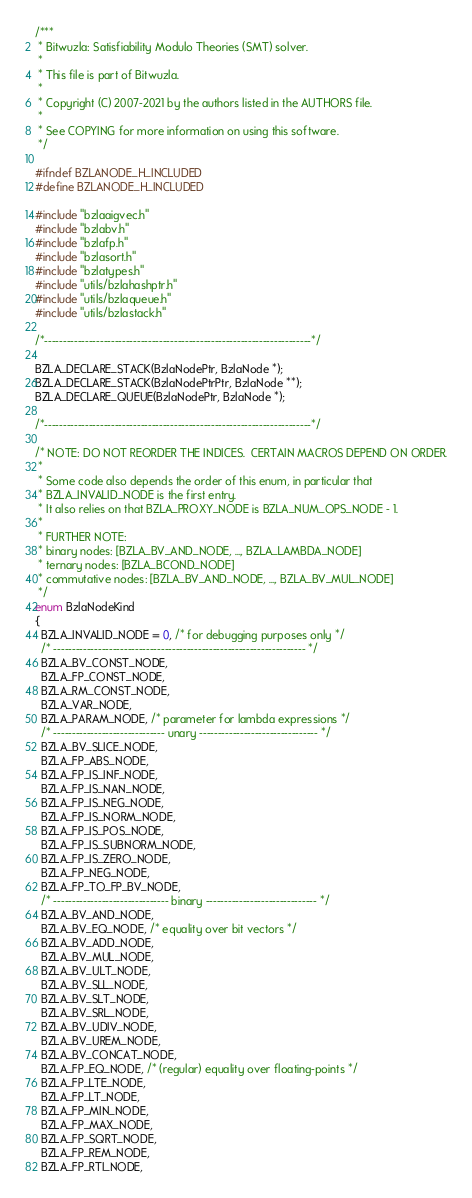Convert code to text. <code><loc_0><loc_0><loc_500><loc_500><_C_>/***
 * Bitwuzla: Satisfiability Modulo Theories (SMT) solver.
 *
 * This file is part of Bitwuzla.
 *
 * Copyright (C) 2007-2021 by the authors listed in the AUTHORS file.
 *
 * See COPYING for more information on using this software.
 */

#ifndef BZLANODE_H_INCLUDED
#define BZLANODE_H_INCLUDED

#include "bzlaaigvec.h"
#include "bzlabv.h"
#include "bzlafp.h"
#include "bzlasort.h"
#include "bzlatypes.h"
#include "utils/bzlahashptr.h"
#include "utils/bzlaqueue.h"
#include "utils/bzlastack.h"

/*------------------------------------------------------------------------*/

BZLA_DECLARE_STACK(BzlaNodePtr, BzlaNode *);
BZLA_DECLARE_STACK(BzlaNodePtrPtr, BzlaNode **);
BZLA_DECLARE_QUEUE(BzlaNodePtr, BzlaNode *);

/*------------------------------------------------------------------------*/

/* NOTE: DO NOT REORDER THE INDICES.  CERTAIN MACROS DEPEND ON ORDER.
 *
 * Some code also depends the order of this enum, in particular that
 * BZLA_INVALID_NODE is the first entry.
 * It also relies on that BZLA_PROXY_NODE is BZLA_NUM_OPS_NODE - 1.
 *
 * FURTHER NOTE:
 * binary nodes: [BZLA_BV_AND_NODE, ..., BZLA_LAMBDA_NODE]
 * ternary nodes: [BZLA_BCOND_NODE]
 * commutative nodes: [BZLA_BV_AND_NODE, ..., BZLA_BV_MUL_NODE]
 */
enum BzlaNodeKind
{
  BZLA_INVALID_NODE = 0, /* for debugging purposes only */
  /* -------------------------------------------------------------------- */
  BZLA_BV_CONST_NODE,
  BZLA_FP_CONST_NODE,
  BZLA_RM_CONST_NODE,
  BZLA_VAR_NODE,
  BZLA_PARAM_NODE, /* parameter for lambda expressions */
  /* ------------------------------ unary -------------------------------- */
  BZLA_BV_SLICE_NODE,
  BZLA_FP_ABS_NODE,
  BZLA_FP_IS_INF_NODE,
  BZLA_FP_IS_NAN_NODE,
  BZLA_FP_IS_NEG_NODE,
  BZLA_FP_IS_NORM_NODE,
  BZLA_FP_IS_POS_NODE,
  BZLA_FP_IS_SUBNORM_NODE,
  BZLA_FP_IS_ZERO_NODE,
  BZLA_FP_NEG_NODE,
  BZLA_FP_TO_FP_BV_NODE,
  /* ------------------------------- binary ------------------------------ */
  BZLA_BV_AND_NODE,
  BZLA_BV_EQ_NODE, /* equality over bit vectors */
  BZLA_BV_ADD_NODE,
  BZLA_BV_MUL_NODE,
  BZLA_BV_ULT_NODE,
  BZLA_BV_SLL_NODE,
  BZLA_BV_SLT_NODE,
  BZLA_BV_SRL_NODE,
  BZLA_BV_UDIV_NODE,
  BZLA_BV_UREM_NODE,
  BZLA_BV_CONCAT_NODE,
  BZLA_FP_EQ_NODE, /* (regular) equality over floating-points */
  BZLA_FP_LTE_NODE,
  BZLA_FP_LT_NODE,
  BZLA_FP_MIN_NODE,
  BZLA_FP_MAX_NODE,
  BZLA_FP_SQRT_NODE,
  BZLA_FP_REM_NODE,
  BZLA_FP_RTI_NODE,</code> 